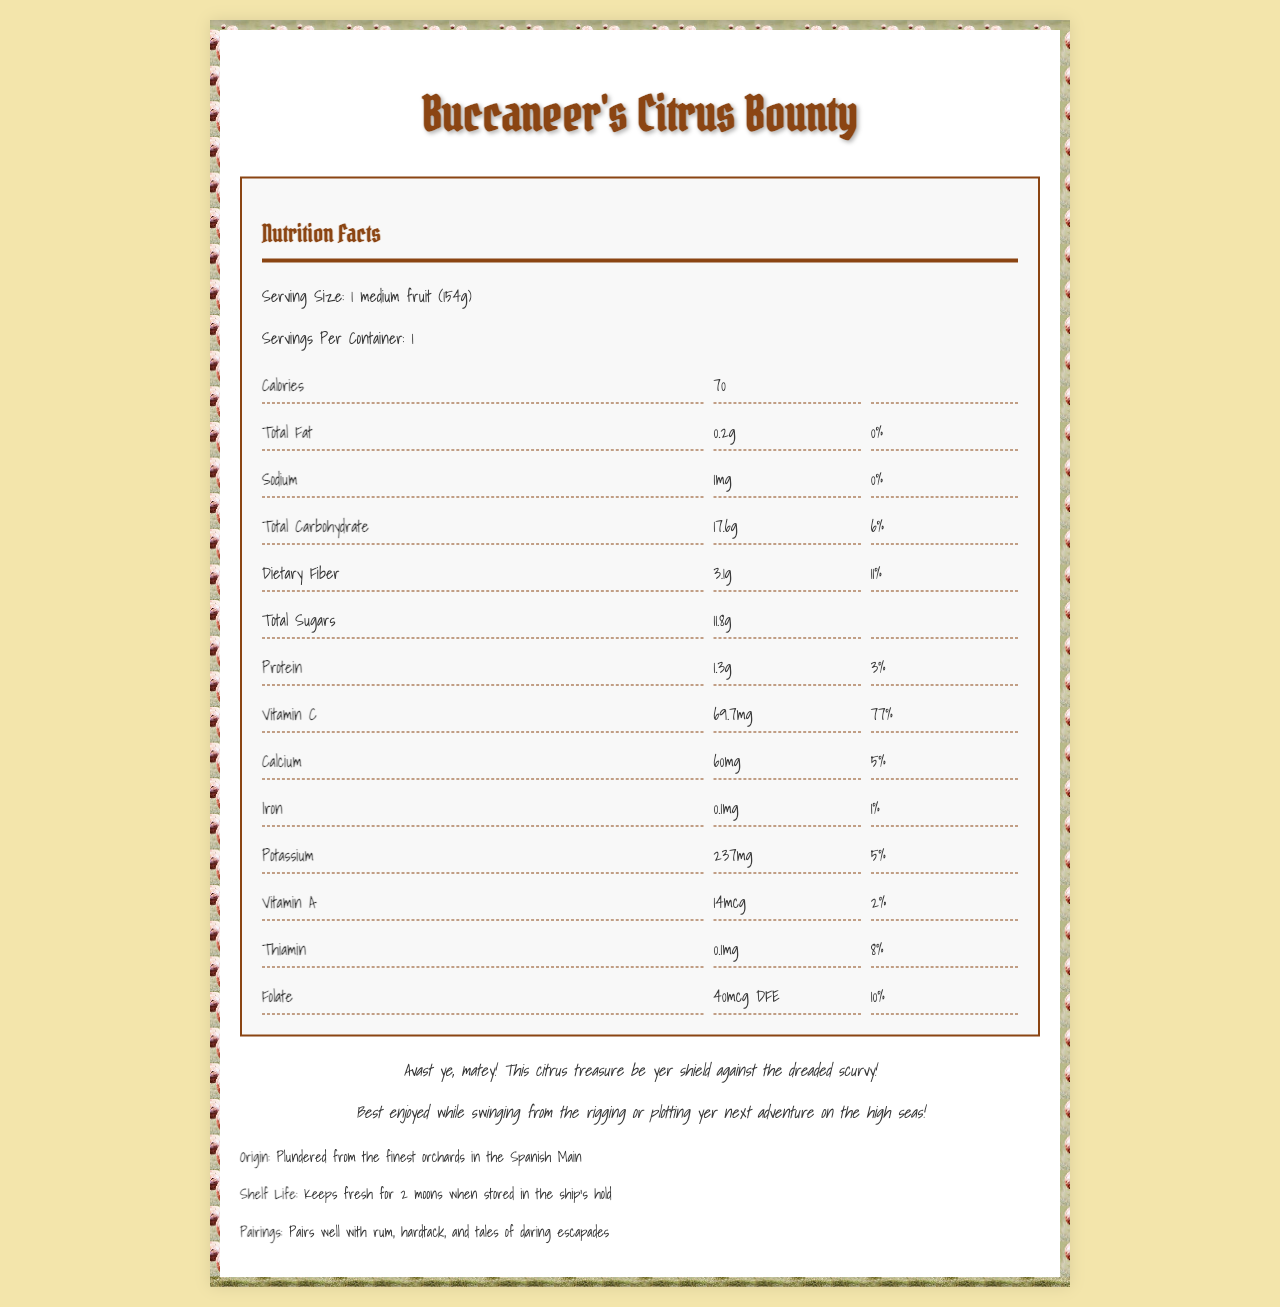how many calories are in a serving? The document states that each serving, which is 1 medium fruit, contains 70 calories.
Answer: 70 what is the daily value percentage for dietary fiber? The document specifies that the daily value percentage for dietary fiber is 11%.
Answer: 11% how much vitamin C is in a serving of Buccaneer's Citrus Bounty? The document lists that each serving contains 69.7mg of vitamin C.
Answer: 69.7mg how can Buccaneer's Citrus Bounty help prevent scurvy? The document explains that the high vitamin C content (77% daily value) of Buccaneer's Citrus Bounty acts as a shield against scurvy.
Answer: It is high in Vitamin C what amount of calcium is provided per serving? The document states that each serving contains 60mg of calcium.
Answer: 60mg which vitamin or mineral has the highest daily value percentage? At 77%, Vitamin C has the highest daily value percentage in the document.
Answer: Vitamin C sum the total carbohydrate content and dietary fiber content for one serving. Total carbohydrate content is 17.6g and dietary fiber is 3.1g. Adding them together gives 20.7g.
Answer: 20.7g how much sodium does Buccaneer's Citrus Bounty contain? A. 10mg B. 70mg C. 1mg The document lists the sodium content as 1mg per serving.
Answer: C: 1mg which component has a daily value percentage of 2%? A. Vitamin A B. Protein C. Calcium The document indicates that Vitamin A has a daily value percentage of 2%.
Answer: A: Vitamin A what is the serving size for Buccaneer's Citrus Bounty? A. 200g B. 100g C. 154g The serving size is listed as 1 medium fruit (154g).
Answer: C: 154g is Buccaneer's Citrus Bounty a good source of iron? The document shows that it only contains 1% of the daily value for iron.
Answer: No describe the main idea of the document. This summary covers the nutritional information and pirate lore provided in the document.
Answer: The document provides nutrition facts for Buccaneer's Citrus Bounty, including serving size, calorie content, and detailed vitamin and mineral information. It emphasizes the high vitamin C content beneficial for preventing scurvy and includes pirate-themed lore about the product's origins and ideal consumption conditions. what is the potassium content per serving? The document states that the potassium content per serving is 237mg.
Answer: 237mg is protein content listed in grams or milligrams? The protein content is listed as 1.3g per serving.
Answer: Grams where were the citrus fruits for Buccaneer's Citrus Bounty sourced from? The additional info section states that the fruits were plundered from the finest orchards in the Spanish Main.
Answer: Spanish Main what are the vitamin C sources listed on the document? The document does not specify the sources of vitamin C for Buccaneer's Citrus Bounty.
Answer: Not specified 